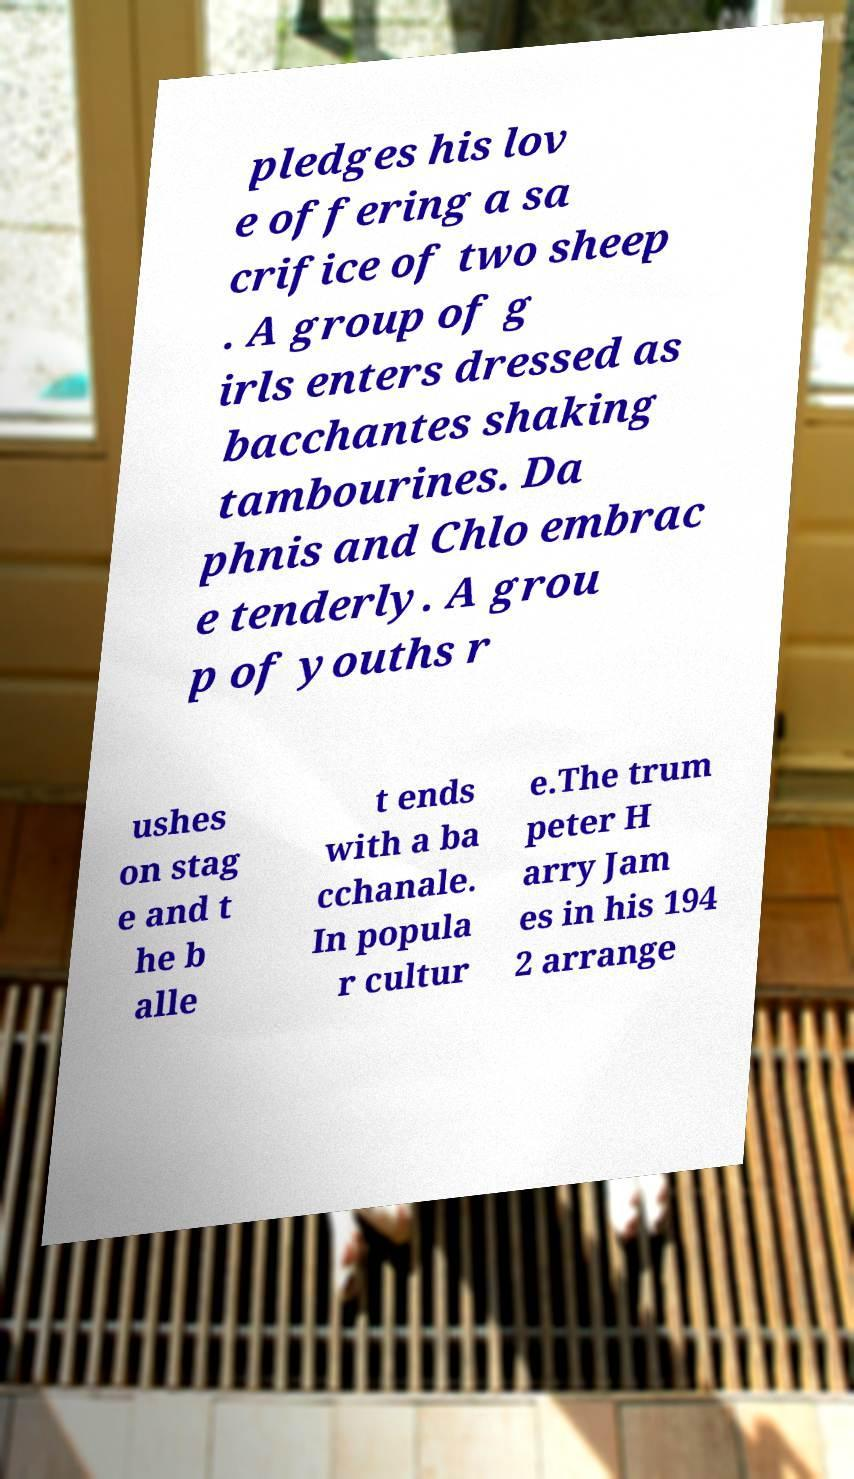Please read and relay the text visible in this image. What does it say? pledges his lov e offering a sa crifice of two sheep . A group of g irls enters dressed as bacchantes shaking tambourines. Da phnis and Chlo embrac e tenderly. A grou p of youths r ushes on stag e and t he b alle t ends with a ba cchanale. In popula r cultur e.The trum peter H arry Jam es in his 194 2 arrange 